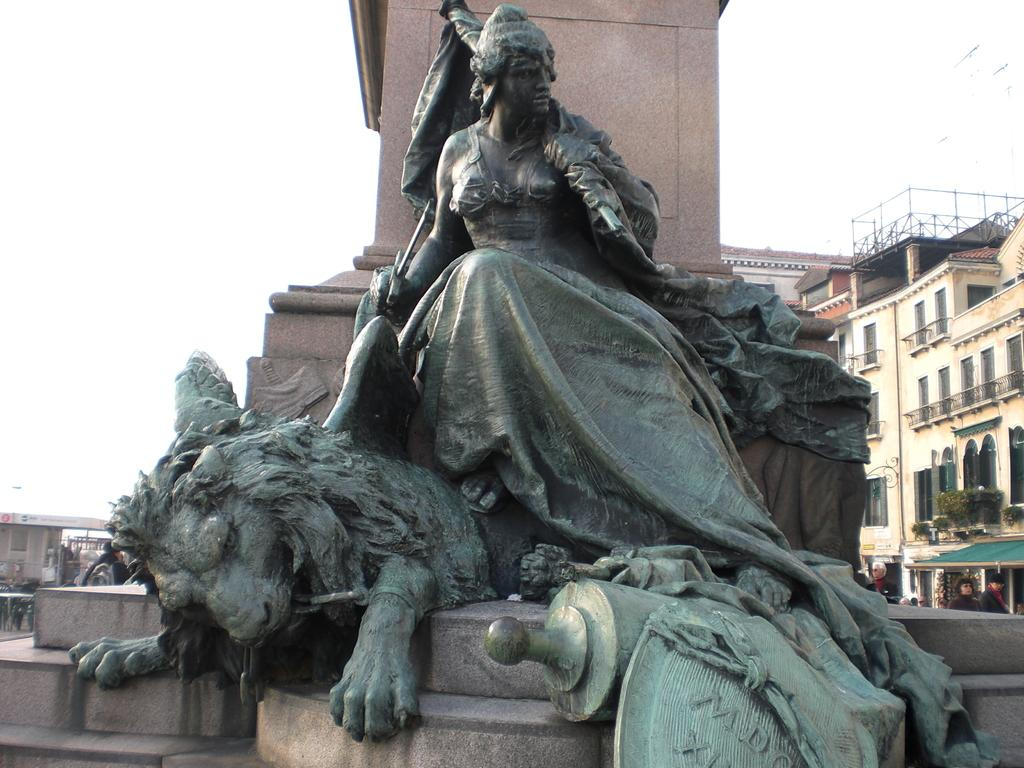What types of statues are in the image? There is a statue of a woman and a statue of an animal in the image. Where are the statues located? Both statues are on a pedestal. What can be seen in the background of the image? The background of the image includes the sky, buildings, windows, plants, people, and pillars. Are there any other objects visible in the background of the image? Yes, there are other objects in the background of the image. What color is the crayon being used by the expert in the image? There is no crayon or expert present in the image. How many pickles are visible on the pedestal with the statues? There are no pickles visible in the image; the pedestal holds statues of a woman and an animal. 